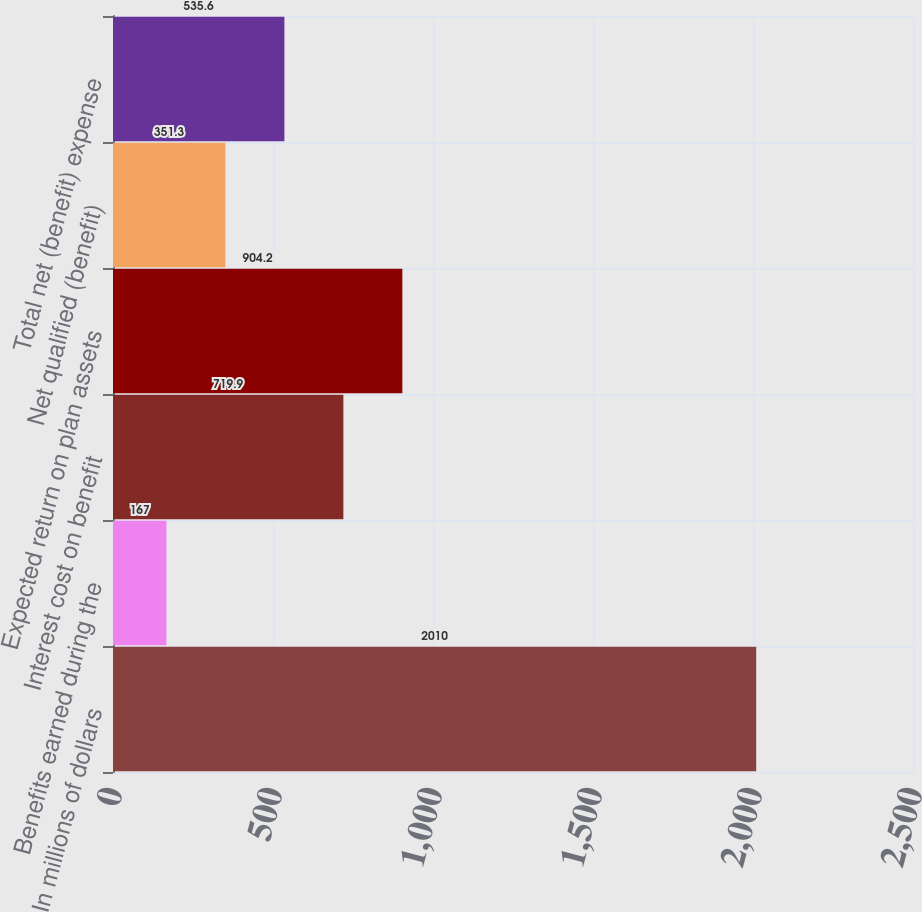Convert chart to OTSL. <chart><loc_0><loc_0><loc_500><loc_500><bar_chart><fcel>In millions of dollars<fcel>Benefits earned during the<fcel>Interest cost on benefit<fcel>Expected return on plan assets<fcel>Net qualified (benefit)<fcel>Total net (benefit) expense<nl><fcel>2010<fcel>167<fcel>719.9<fcel>904.2<fcel>351.3<fcel>535.6<nl></chart> 